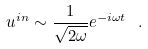Convert formula to latex. <formula><loc_0><loc_0><loc_500><loc_500>u ^ { i n } \sim \frac { 1 } { \sqrt { 2 \omega } } e ^ { - i \omega t } \ .</formula> 